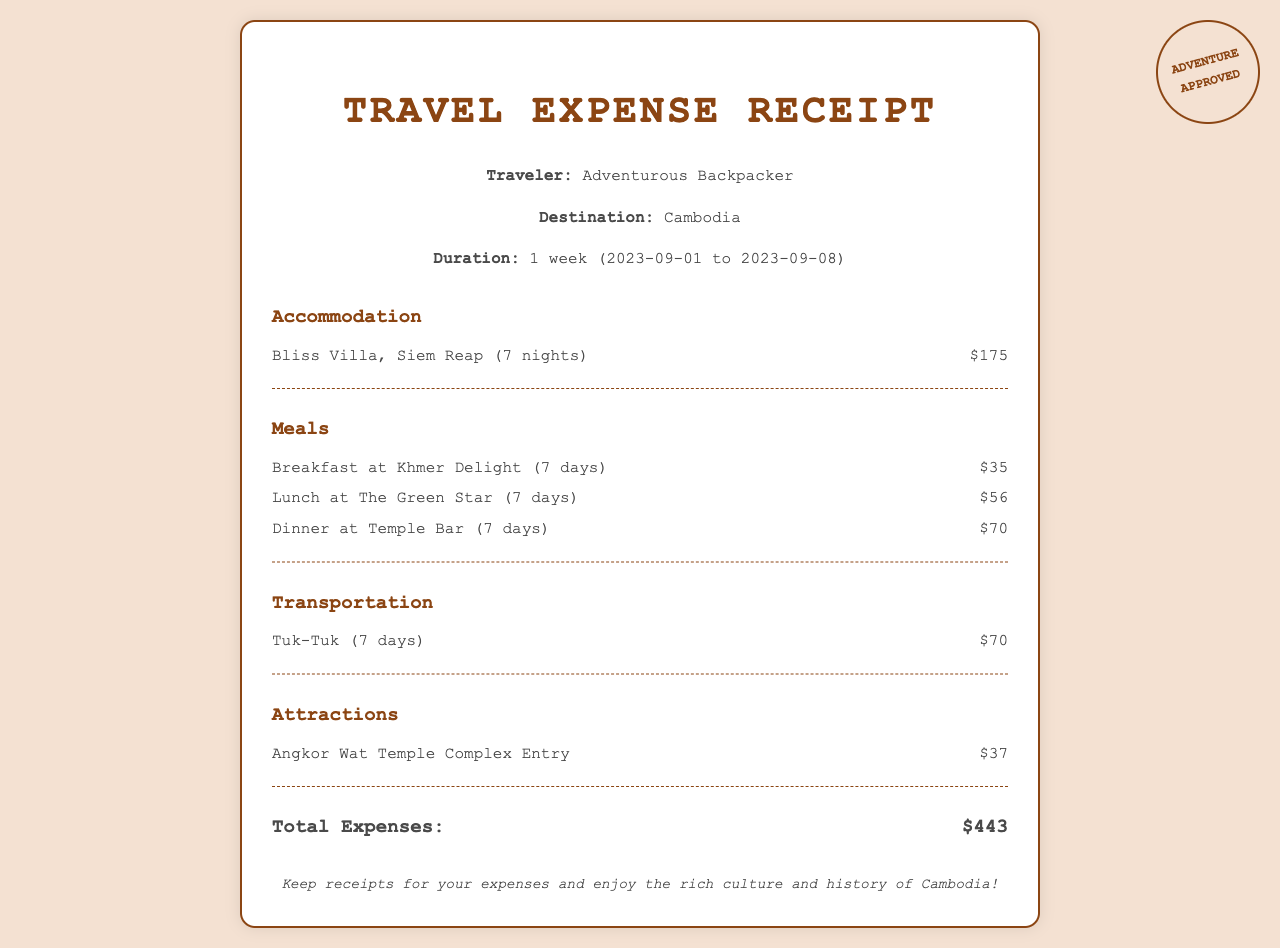What was the accommodation cost for the week? The accommodation cost is listed under "Accommodation" in the document, which shows Bliss Villa for 7 nights at $175.
Answer: $175 How many days did the meals total cost? The meals' costs are provided for breakfast, lunch, and dinner across 7 days.
Answer: 7 days What is the total transportation cost? The transportation cost for Tuk-Tuk over 7 days is summarized in the "Transportation" section.
Answer: $70 What was the price for the Angkor Wat Temple Complex entry? This information is found under the "Attractions" category, specifically mentioning the cost of entry to Angkor Wat.
Answer: $37 What is the total expenses for the week? The total expenses are calculated at the bottom of the receipt, aggregating all costs presented in various categories.
Answer: $443 Where did breakfast take place? The breakfast location, "Khmer Delight," is specified in the "Meals" category of the receipt.
Answer: Khmer Delight What is the duration of the trip in days? The receipt mentions that the trip's duration is 1 week, which consists of 7 days.
Answer: 7 days What type of document is this? The title at the top of the document indicates it is a "Travel Expense Receipt."
Answer: Travel Expense Receipt Which meal cost the most? Reviewing the "Meals" section, one can see that dinner at Temple Bar for 7 days accumulates to the highest cost.
Answer: Dinner at Temple Bar 